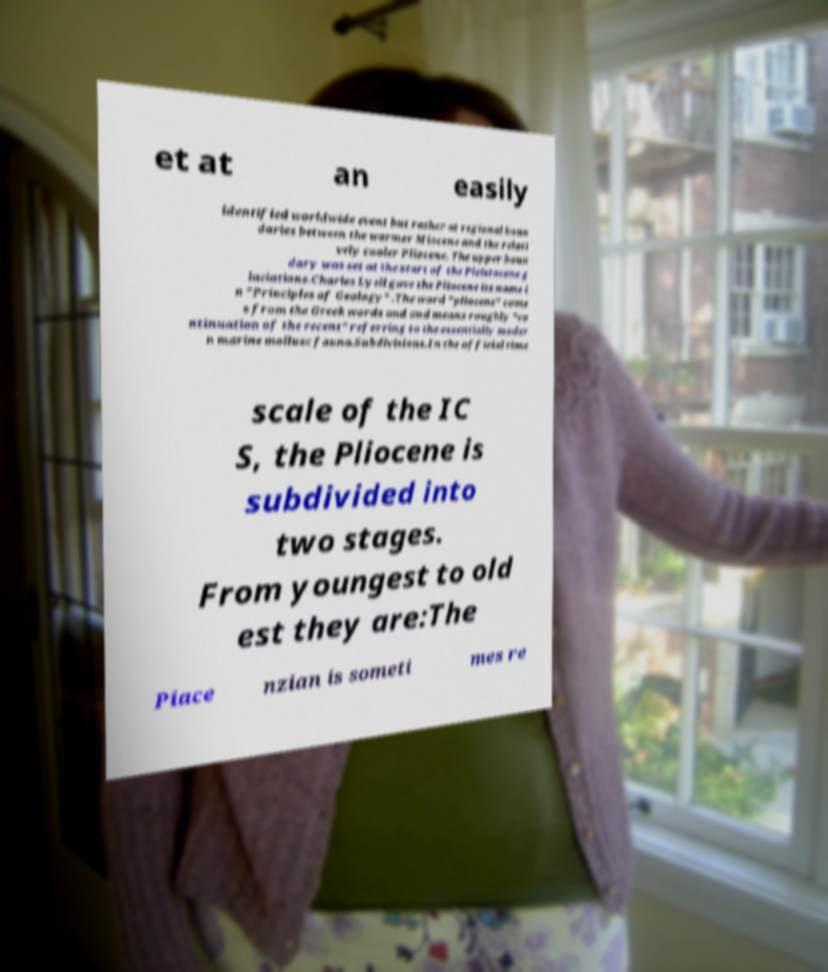What messages or text are displayed in this image? I need them in a readable, typed format. et at an easily identified worldwide event but rather at regional boun daries between the warmer Miocene and the relati vely cooler Pliocene. The upper boun dary was set at the start of the Pleistocene g laciations.Charles Lyell gave the Pliocene its name i n "Principles of Geology" .The word "pliocene" come s from the Greek words and and means roughly "co ntinuation of the recent" referring to the essentially moder n marine mollusc fauna.Subdivisions.In the official time scale of the IC S, the Pliocene is subdivided into two stages. From youngest to old est they are:The Piace nzian is someti mes re 